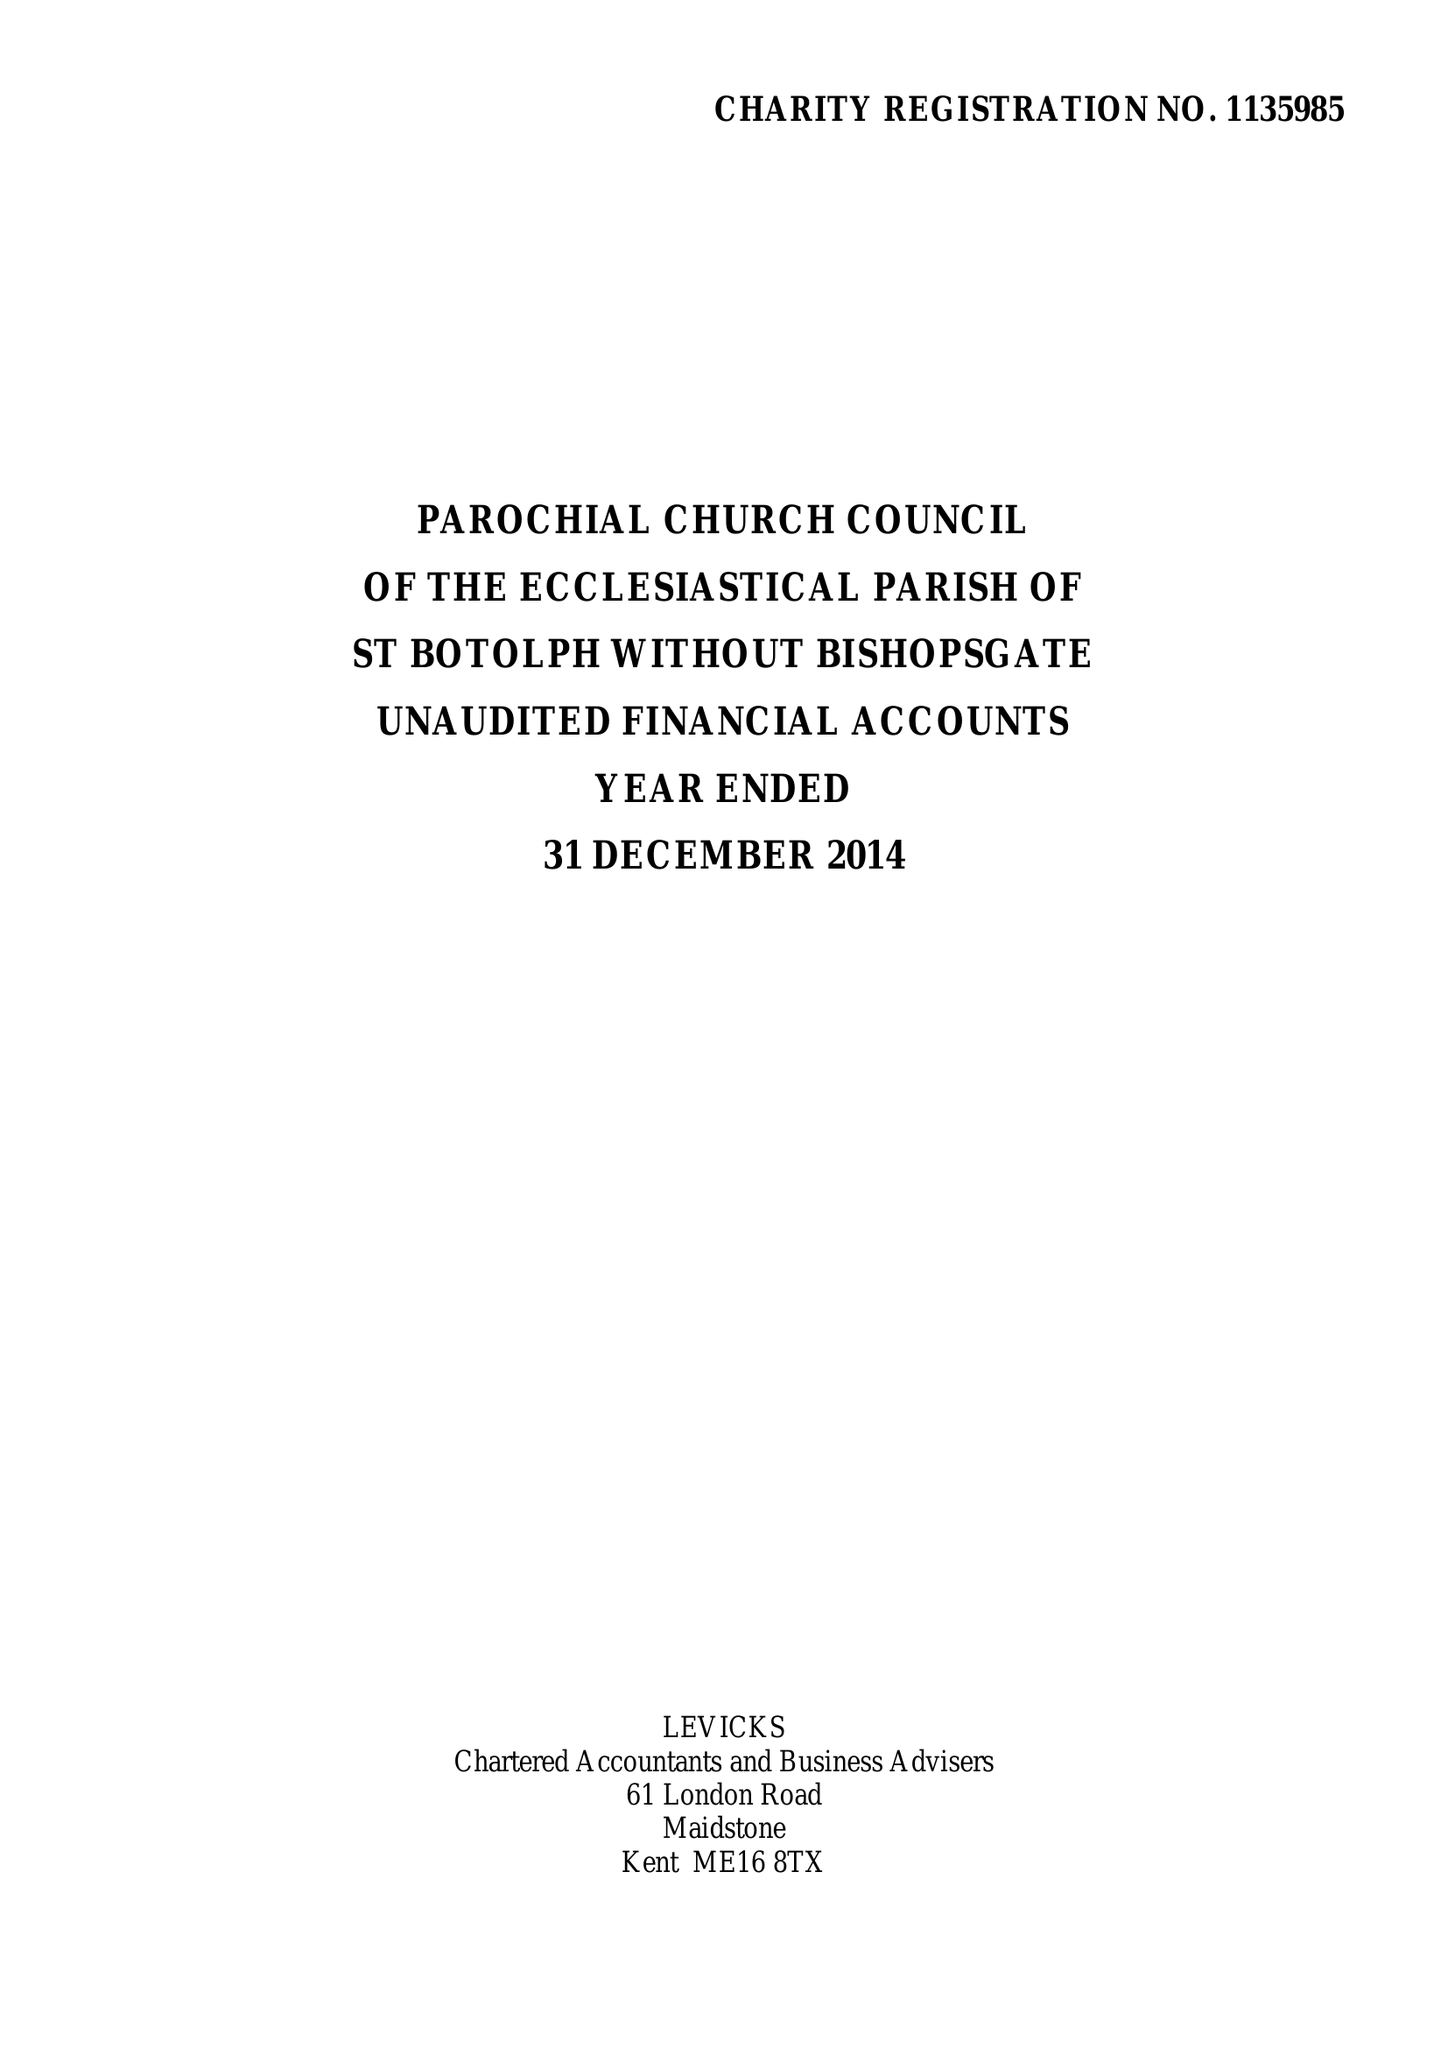What is the value for the address__postcode?
Answer the question using a single word or phrase. EC2M 3TL 